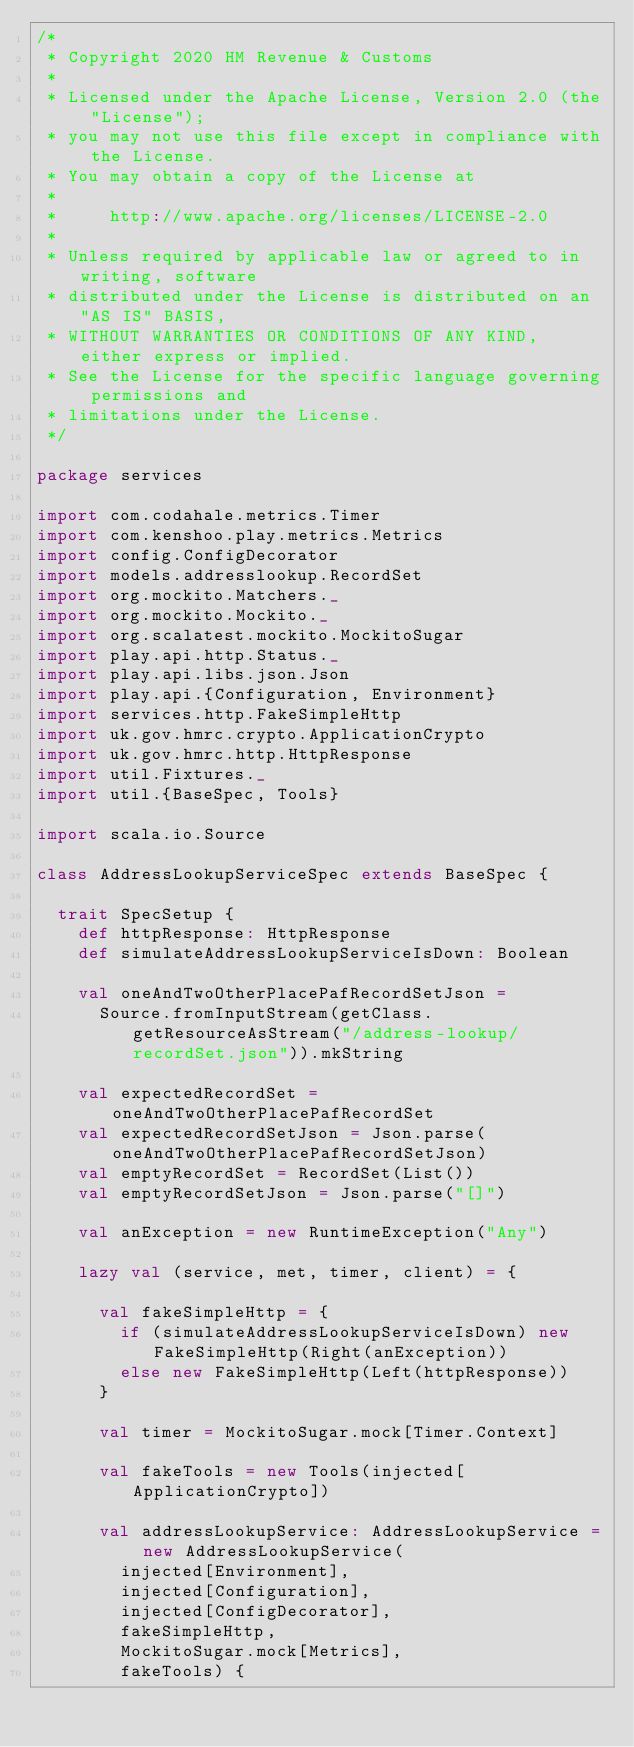Convert code to text. <code><loc_0><loc_0><loc_500><loc_500><_Scala_>/*
 * Copyright 2020 HM Revenue & Customs
 *
 * Licensed under the Apache License, Version 2.0 (the "License");
 * you may not use this file except in compliance with the License.
 * You may obtain a copy of the License at
 *
 *     http://www.apache.org/licenses/LICENSE-2.0
 *
 * Unless required by applicable law or agreed to in writing, software
 * distributed under the License is distributed on an "AS IS" BASIS,
 * WITHOUT WARRANTIES OR CONDITIONS OF ANY KIND, either express or implied.
 * See the License for the specific language governing permissions and
 * limitations under the License.
 */

package services

import com.codahale.metrics.Timer
import com.kenshoo.play.metrics.Metrics
import config.ConfigDecorator
import models.addresslookup.RecordSet
import org.mockito.Matchers._
import org.mockito.Mockito._
import org.scalatest.mockito.MockitoSugar
import play.api.http.Status._
import play.api.libs.json.Json
import play.api.{Configuration, Environment}
import services.http.FakeSimpleHttp
import uk.gov.hmrc.crypto.ApplicationCrypto
import uk.gov.hmrc.http.HttpResponse
import util.Fixtures._
import util.{BaseSpec, Tools}

import scala.io.Source

class AddressLookupServiceSpec extends BaseSpec {

  trait SpecSetup {
    def httpResponse: HttpResponse
    def simulateAddressLookupServiceIsDown: Boolean

    val oneAndTwoOtherPlacePafRecordSetJson =
      Source.fromInputStream(getClass.getResourceAsStream("/address-lookup/recordSet.json")).mkString

    val expectedRecordSet = oneAndTwoOtherPlacePafRecordSet
    val expectedRecordSetJson = Json.parse(oneAndTwoOtherPlacePafRecordSetJson)
    val emptyRecordSet = RecordSet(List())
    val emptyRecordSetJson = Json.parse("[]")

    val anException = new RuntimeException("Any")

    lazy val (service, met, timer, client) = {

      val fakeSimpleHttp = {
        if (simulateAddressLookupServiceIsDown) new FakeSimpleHttp(Right(anException))
        else new FakeSimpleHttp(Left(httpResponse))
      }

      val timer = MockitoSugar.mock[Timer.Context]

      val fakeTools = new Tools(injected[ApplicationCrypto])

      val addressLookupService: AddressLookupService = new AddressLookupService(
        injected[Environment],
        injected[Configuration],
        injected[ConfigDecorator],
        fakeSimpleHttp,
        MockitoSugar.mock[Metrics],
        fakeTools) {</code> 